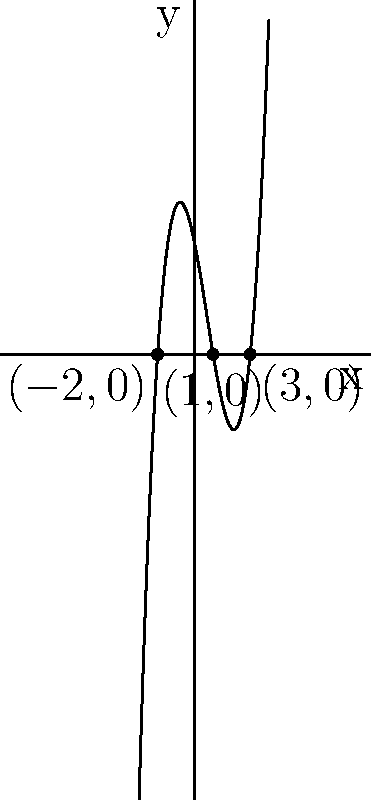As a meticulous repairman, you're tasked with sketching the graph of a polynomial function. The function has roots at $x=-2$, $x=1$, and $x=3$. The graph passes through these points and opens upward. Determine the equation of this polynomial function in its factored form. Let's approach this step-by-step:

1) We know the roots of the polynomial are at $x=-2$, $x=1$, and $x=3$. This means the function can be written in the form:

   $f(x) = a(x+2)(x-1)(x-3)$

   where $a$ is a non-zero constant.

2) We're told the graph opens upward. This means that as $x$ approaches positive or negative infinity, $f(x)$ approaches positive infinity. For this to be true, $a$ must be positive.

3) The simplest choice for $a$ is 1, which will give us the monic polynomial (leading coefficient of 1).

4) Therefore, the equation of the polynomial in factored form is:

   $f(x) = (x+2)(x-1)(x-3)$

5) If we expand this, we get:

   $f(x) = (x+2)(x^2-4x+3)$
         $= x^3-4x^2+3x+2x^2-8x+6$
         $= x^3-2x^2-5x+6$

However, the question asks for the factored form, so we'll stick with the factored version as our final answer.
Answer: $f(x) = (x+2)(x-1)(x-3)$ 